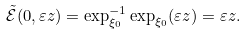<formula> <loc_0><loc_0><loc_500><loc_500>\tilde { \mathcal { E } } ( 0 , \varepsilon z ) = \exp _ { \xi _ { 0 } } ^ { - 1 } \exp _ { \xi _ { 0 } } ( \varepsilon z ) = \varepsilon z .</formula> 